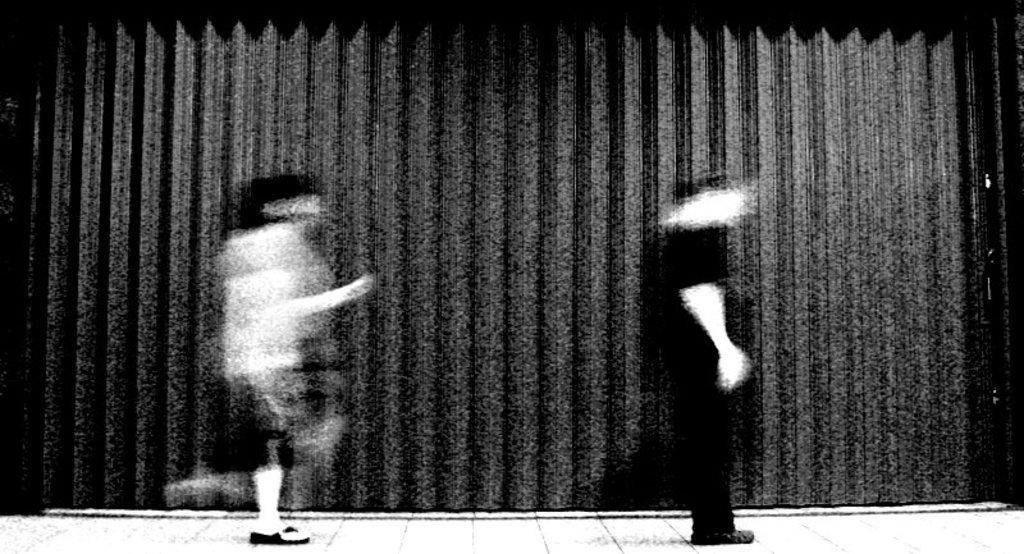What is the color scheme of the image? The image is black and white. Who are the people in the image? There is a man and a woman in the image. What are the positions of the man and the woman in the image? Both the man and the woman are on the floor. How far away is the jellyfish from the man and woman in the image? There is no jellyfish present in the image. 